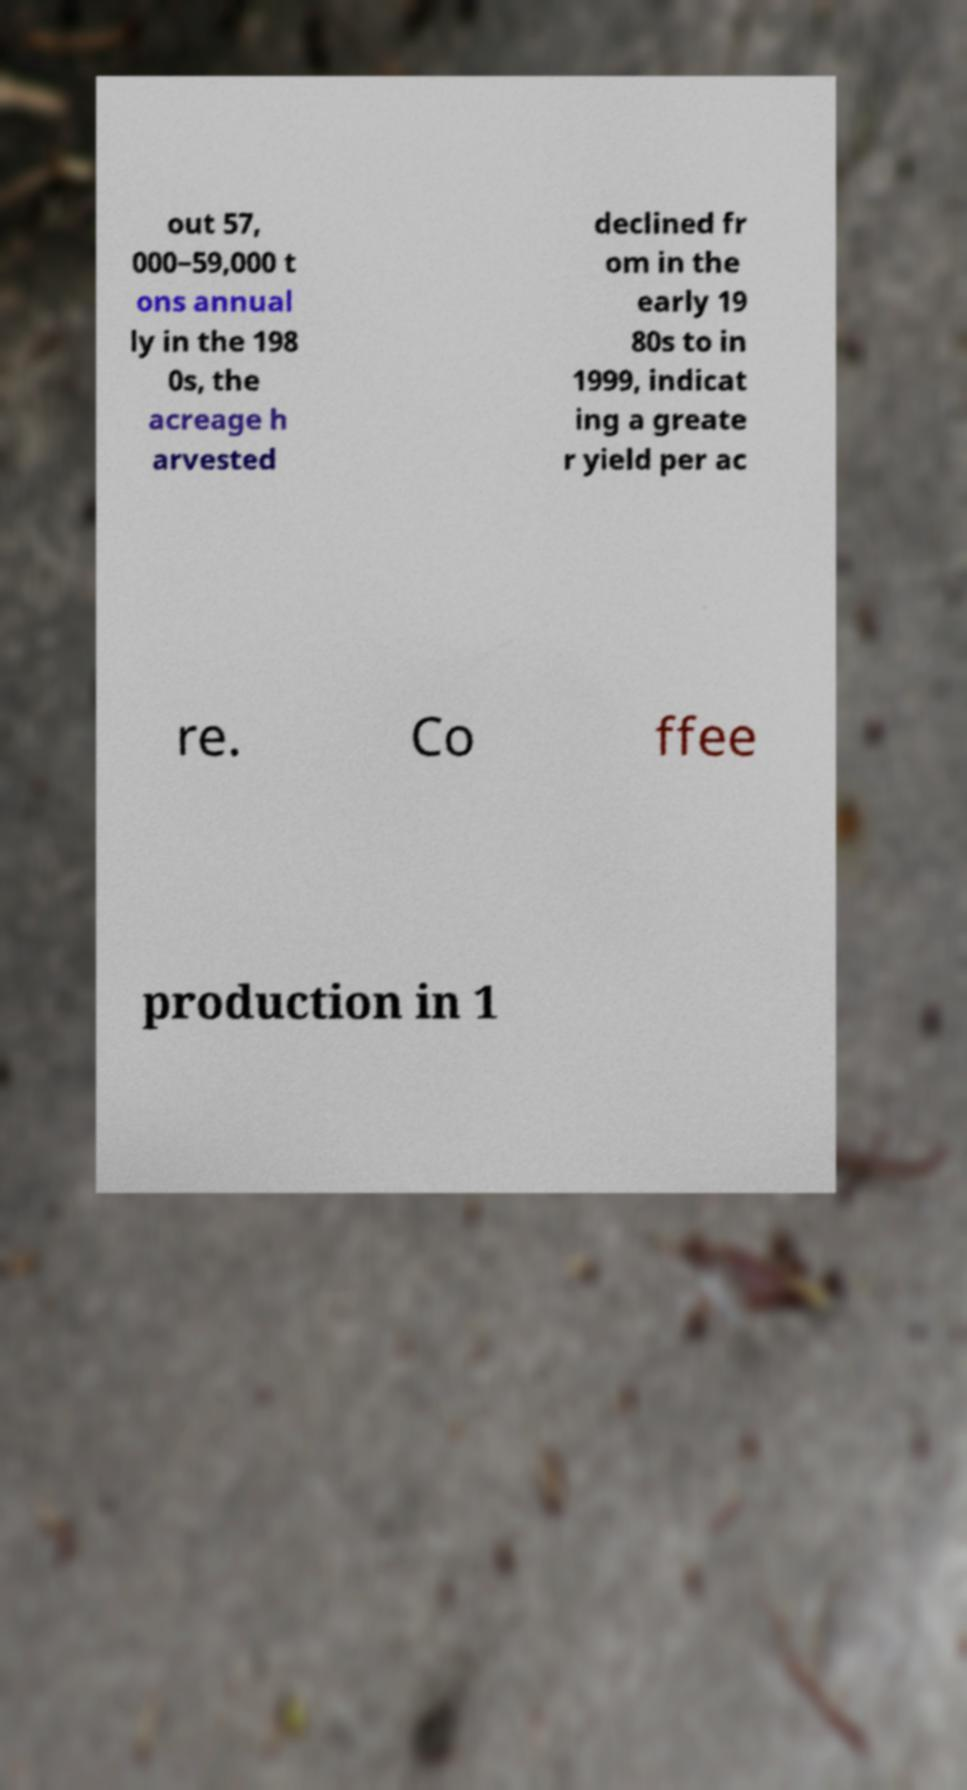Please read and relay the text visible in this image. What does it say? out 57, 000–59,000 t ons annual ly in the 198 0s, the acreage h arvested declined fr om in the early 19 80s to in 1999, indicat ing a greate r yield per ac re. Co ffee production in 1 